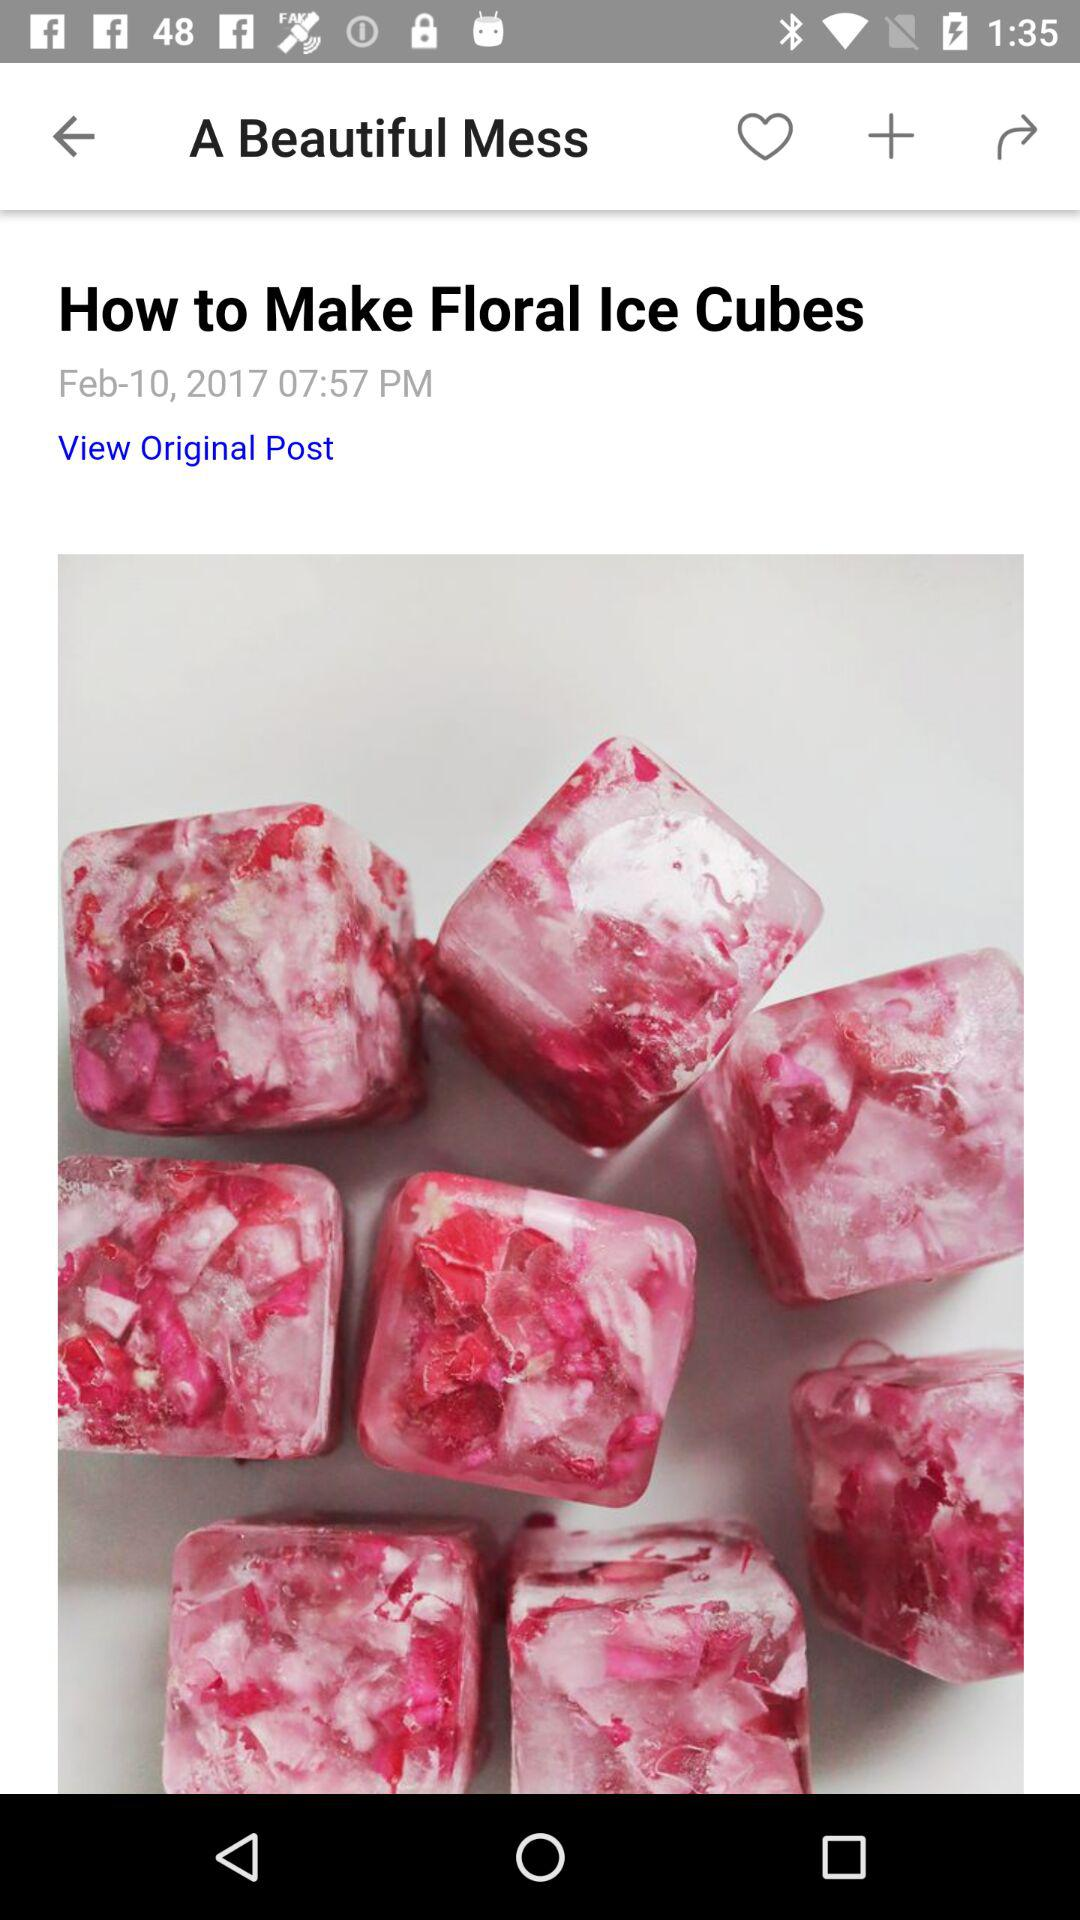How long does it take to prepare the ice cubes?
When the provided information is insufficient, respond with <no answer>. <no answer> 